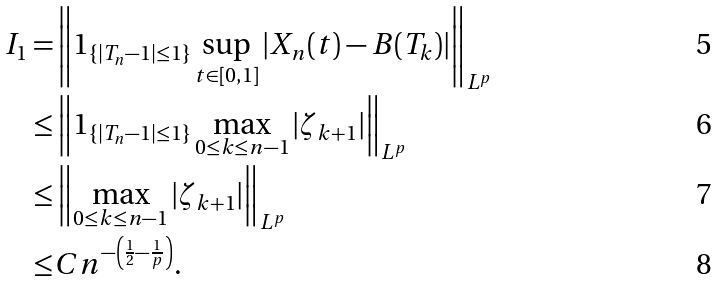<formula> <loc_0><loc_0><loc_500><loc_500>I _ { 1 } = & \left \| 1 _ { \{ | T _ { n } - 1 | \leq 1 \} } \sup _ { t \in [ 0 , 1 ] } | X _ { n } ( t ) - B ( T _ { k } ) | \right \| _ { L ^ { p } } \\ \leq & \left \| 1 _ { \{ | T _ { n } - 1 | \leq 1 \} } \max _ { 0 \leq k \leq n - 1 } | \zeta _ { k + 1 } | \right \| _ { L ^ { p } } \\ \leq & \left \| \max _ { 0 \leq k \leq n - 1 } | \zeta _ { k + 1 } | \right \| _ { L ^ { p } } \\ \leq & C n ^ { - \left ( \frac { 1 } { 2 } - \frac { 1 } { p } \right ) } .</formula> 